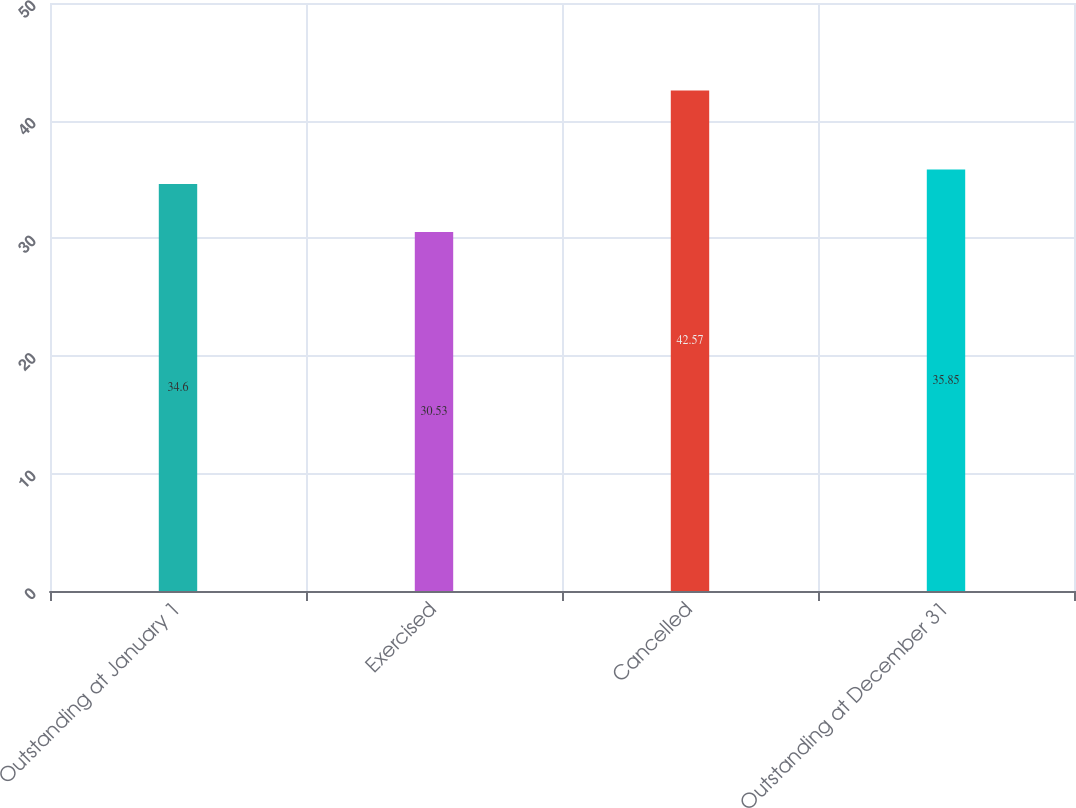<chart> <loc_0><loc_0><loc_500><loc_500><bar_chart><fcel>Outstanding at January 1<fcel>Exercised<fcel>Cancelled<fcel>Outstanding at December 31<nl><fcel>34.6<fcel>30.53<fcel>42.57<fcel>35.85<nl></chart> 